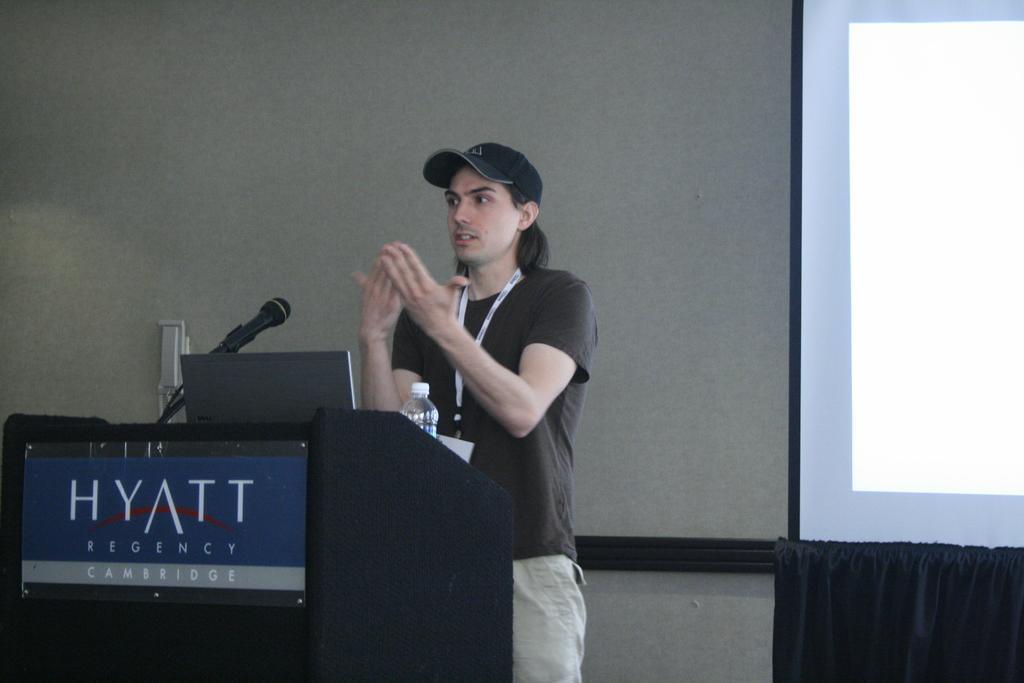Please provide a concise description of this image. In this image a person is standing behind the podium. On the podium there is a laptop, mic and a bottle. Person is wearing a cap. Right side there is a screen. Behind there is a wall. 